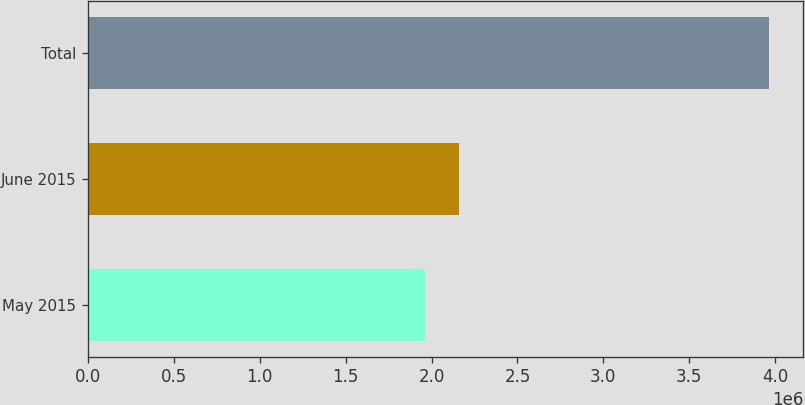Convert chart. <chart><loc_0><loc_0><loc_500><loc_500><bar_chart><fcel>May 2015<fcel>June 2015<fcel>Total<nl><fcel>1.95956e+06<fcel>2.16021e+06<fcel>3.96602e+06<nl></chart> 